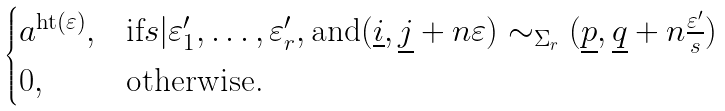<formula> <loc_0><loc_0><loc_500><loc_500>\begin{cases} a ^ { \text {ht} ( \varepsilon ) } , & \text {if} s | \varepsilon ^ { \prime } _ { 1 } , \dots , \varepsilon ^ { \prime } _ { r } , \text {and} ( \underline { i } , \underline { j } + n \varepsilon ) \sim _ { \Sigma _ { r } } ( \underline { p } , \underline { q } + n \frac { \varepsilon ^ { \prime } } { s } ) \\ 0 , & \text {otherwise.} \end{cases}</formula> 